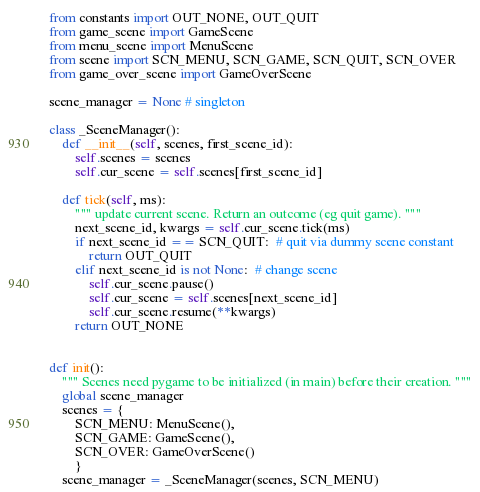<code> <loc_0><loc_0><loc_500><loc_500><_Python_>from constants import OUT_NONE, OUT_QUIT
from game_scene import GameScene
from menu_scene import MenuScene
from scene import SCN_MENU, SCN_GAME, SCN_QUIT, SCN_OVER
from game_over_scene import GameOverScene

scene_manager = None # singleton

class _SceneManager():
    def __init__(self, scenes, first_scene_id):
        self.scenes = scenes
        self.cur_scene = self.scenes[first_scene_id]

    def tick(self, ms):
        """ update current scene. Return an outcome (eg quit game). """
        next_scene_id, kwargs = self.cur_scene.tick(ms)
        if next_scene_id == SCN_QUIT:  # quit via dummy scene constant
            return OUT_QUIT
        elif next_scene_id is not None:  # change scene
            self.cur_scene.pause()
            self.cur_scene = self.scenes[next_scene_id]
            self.cur_scene.resume(**kwargs)
        return OUT_NONE
    
    
def init():
    """ Scenes need pygame to be initialized (in main) before their creation. """
    global scene_manager
    scenes = { 
        SCN_MENU: MenuScene(), 
        SCN_GAME: GameScene(),
        SCN_OVER: GameOverScene() 
        }
    scene_manager = _SceneManager(scenes, SCN_MENU)
</code> 